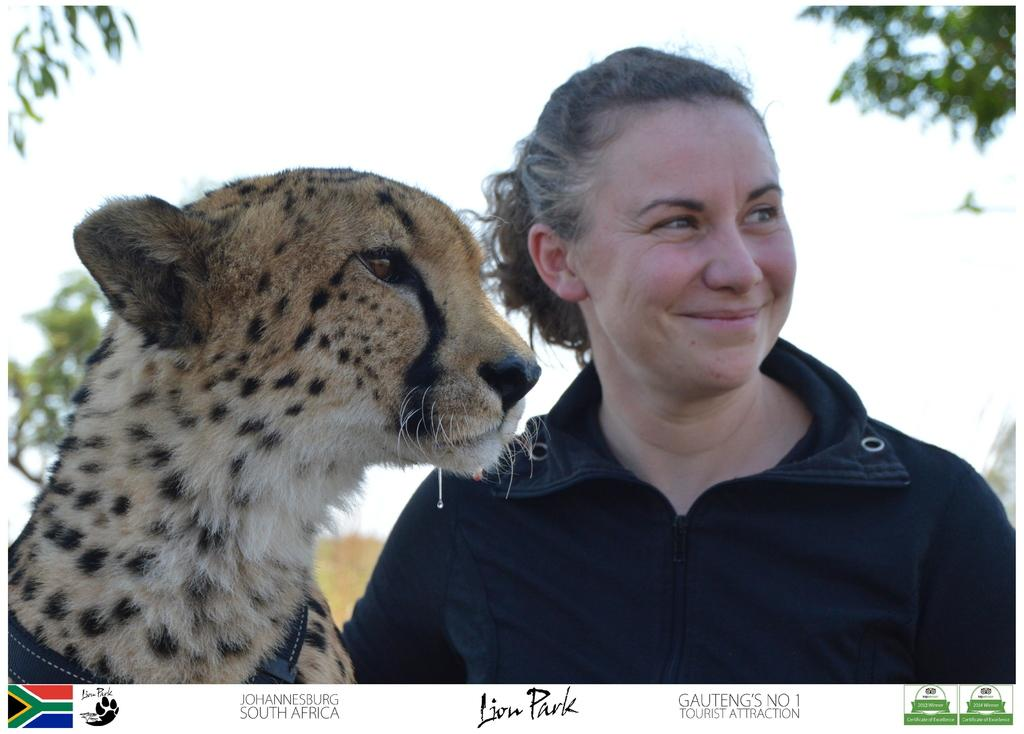What is the woman doing in the image? The woman is standing and smiling in the image. What animal is present in the image? There is a cheetah in the image. What can be seen in the background of the image? There are trees in the background of the image. What natural element is visible in the image? Water is visible in the image. Can you describe any additional features of the image? The image has watermarks. What type of cent can be seen interacting with the cheetah in the image? There is no cent present in the image, and therefore no such interaction can be observed. 